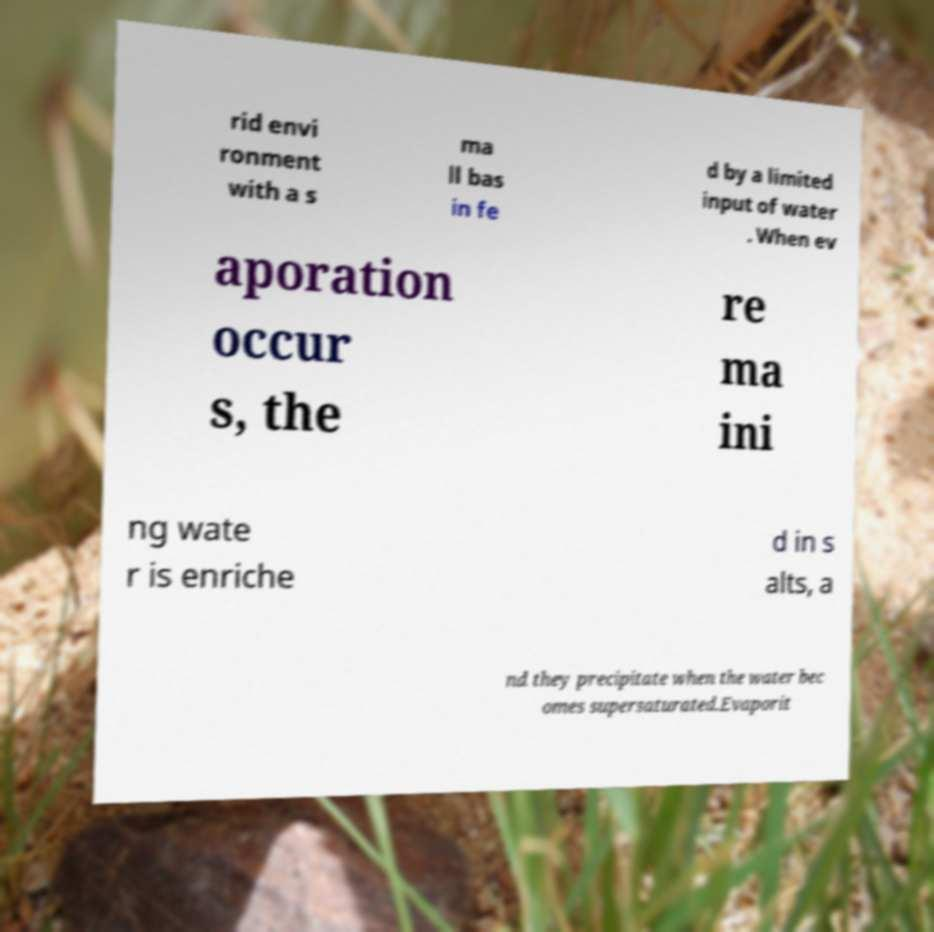Please identify and transcribe the text found in this image. rid envi ronment with a s ma ll bas in fe d by a limited input of water . When ev aporation occur s, the re ma ini ng wate r is enriche d in s alts, a nd they precipitate when the water bec omes supersaturated.Evaporit 